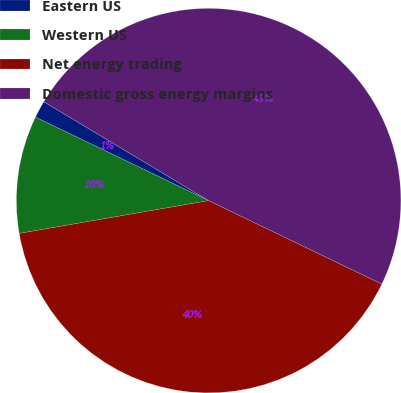Convert chart to OTSL. <chart><loc_0><loc_0><loc_500><loc_500><pie_chart><fcel>Eastern US<fcel>Western US<fcel>Net energy trading<fcel>Domestic gross energy margins<nl><fcel>1.45%<fcel>9.88%<fcel>40.12%<fcel>48.55%<nl></chart> 